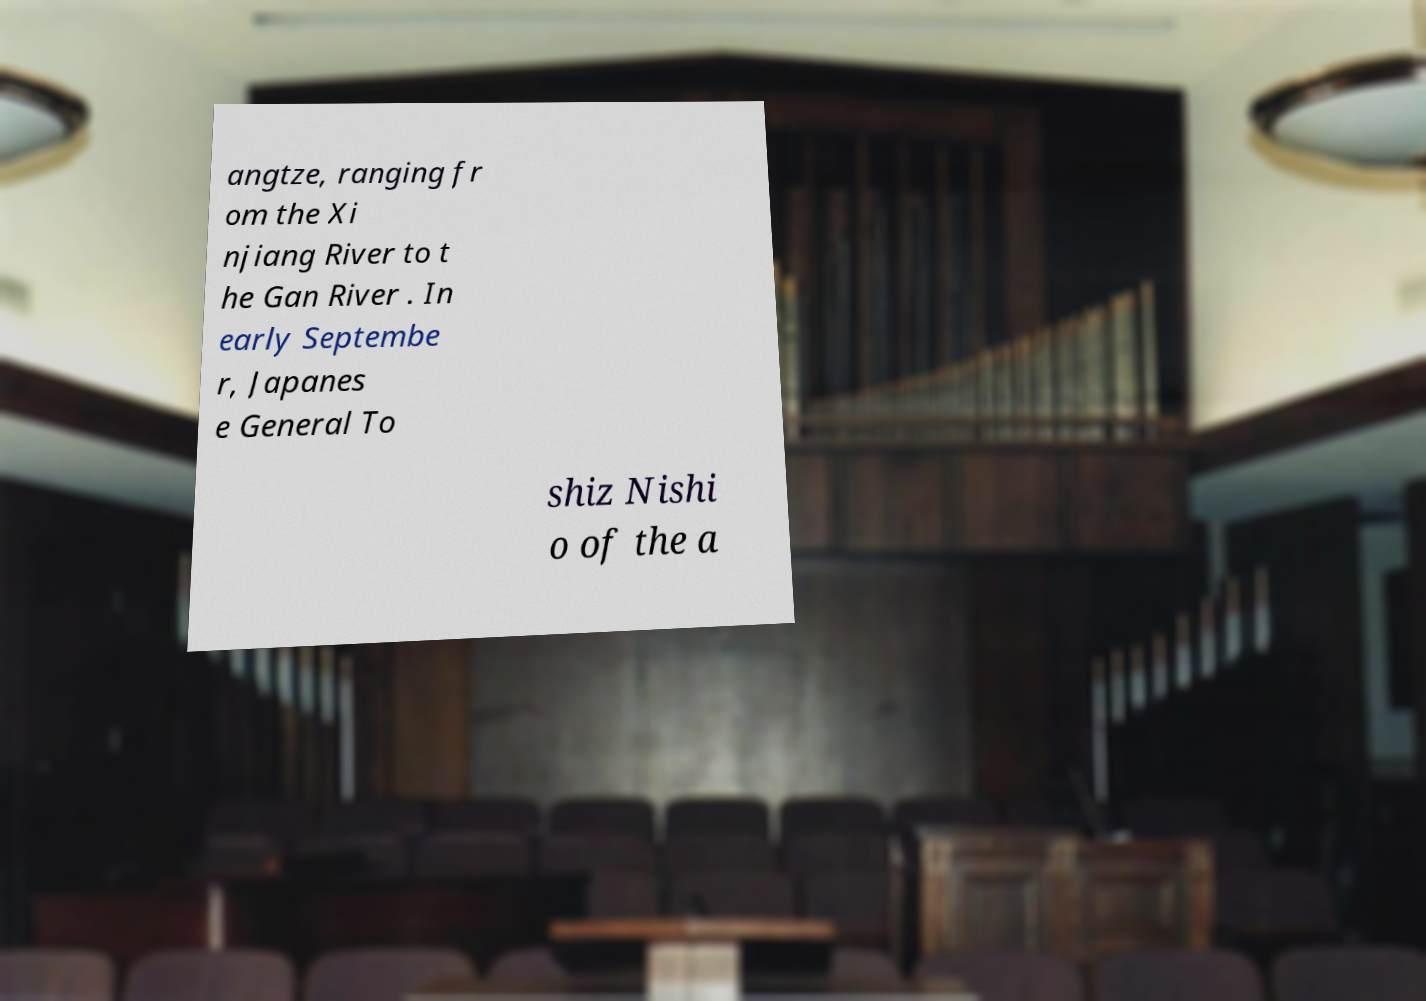There's text embedded in this image that I need extracted. Can you transcribe it verbatim? angtze, ranging fr om the Xi njiang River to t he Gan River . In early Septembe r, Japanes e General To shiz Nishi o of the a 